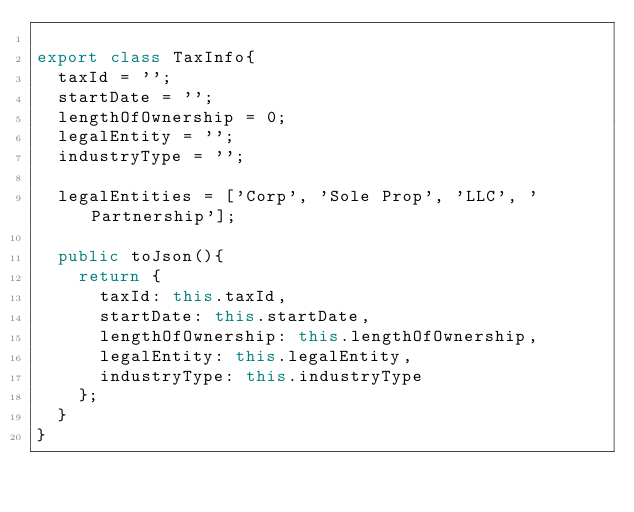Convert code to text. <code><loc_0><loc_0><loc_500><loc_500><_TypeScript_>
export class TaxInfo{
  taxId = '';
  startDate = '';
  lengthOfOwnership = 0;
  legalEntity = '';
  industryType = '';

  legalEntities = ['Corp', 'Sole Prop', 'LLC', 'Partnership'];

  public toJson(){
    return {
      taxId: this.taxId,
      startDate: this.startDate,
      lengthOfOwnership: this.lengthOfOwnership,
      legalEntity: this.legalEntity,
      industryType: this.industryType
    };
  }
}
</code> 